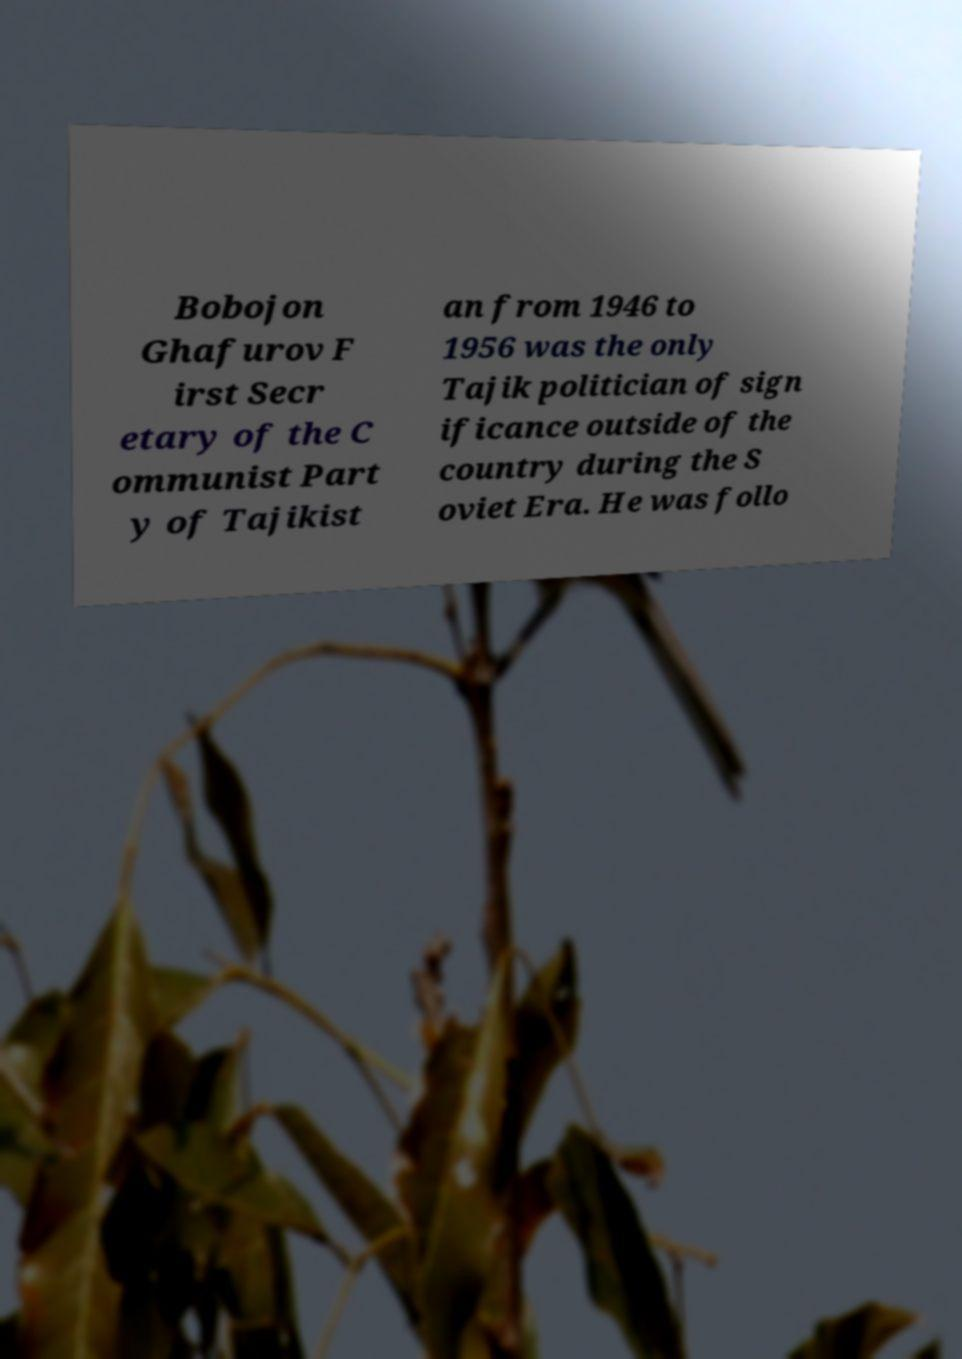Can you accurately transcribe the text from the provided image for me? Bobojon Ghafurov F irst Secr etary of the C ommunist Part y of Tajikist an from 1946 to 1956 was the only Tajik politician of sign ificance outside of the country during the S oviet Era. He was follo 